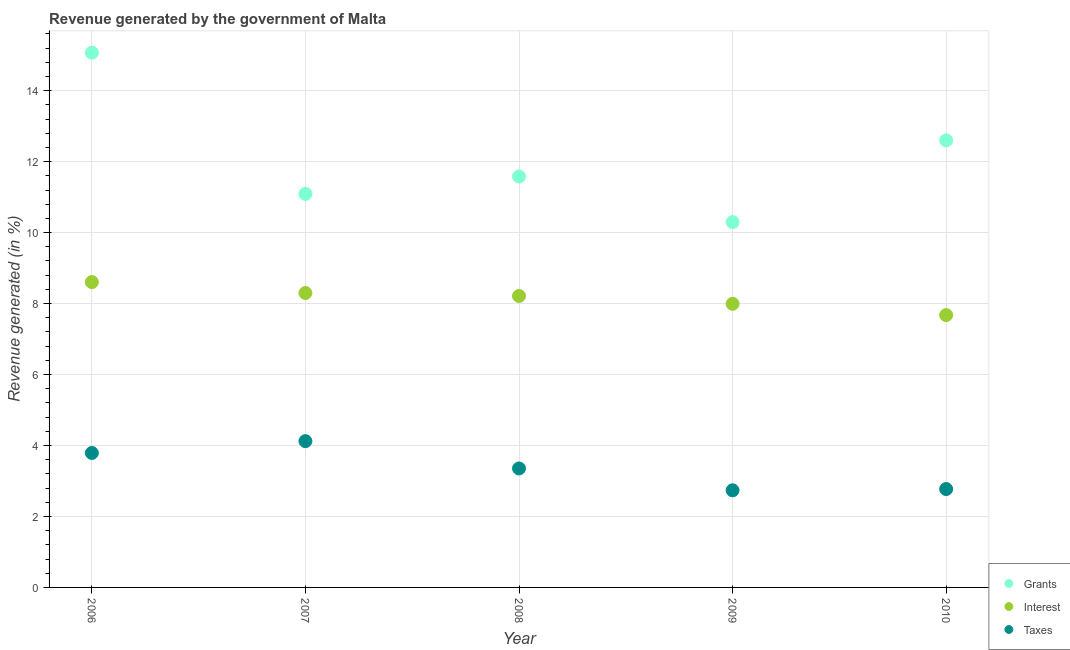How many different coloured dotlines are there?
Keep it short and to the point. 3. Is the number of dotlines equal to the number of legend labels?
Provide a succinct answer. Yes. What is the percentage of revenue generated by grants in 2010?
Give a very brief answer. 12.6. Across all years, what is the maximum percentage of revenue generated by taxes?
Give a very brief answer. 4.12. Across all years, what is the minimum percentage of revenue generated by interest?
Offer a terse response. 7.67. In which year was the percentage of revenue generated by taxes maximum?
Provide a succinct answer. 2007. In which year was the percentage of revenue generated by taxes minimum?
Provide a short and direct response. 2009. What is the total percentage of revenue generated by taxes in the graph?
Ensure brevity in your answer.  16.77. What is the difference between the percentage of revenue generated by interest in 2007 and that in 2009?
Provide a short and direct response. 0.3. What is the difference between the percentage of revenue generated by taxes in 2006 and the percentage of revenue generated by interest in 2009?
Give a very brief answer. -4.2. What is the average percentage of revenue generated by interest per year?
Your response must be concise. 8.16. In the year 2006, what is the difference between the percentage of revenue generated by grants and percentage of revenue generated by interest?
Your response must be concise. 6.46. What is the ratio of the percentage of revenue generated by taxes in 2006 to that in 2007?
Give a very brief answer. 0.92. Is the percentage of revenue generated by taxes in 2006 less than that in 2008?
Your response must be concise. No. Is the difference between the percentage of revenue generated by grants in 2006 and 2008 greater than the difference between the percentage of revenue generated by taxes in 2006 and 2008?
Give a very brief answer. Yes. What is the difference between the highest and the second highest percentage of revenue generated by taxes?
Keep it short and to the point. 0.33. What is the difference between the highest and the lowest percentage of revenue generated by taxes?
Offer a very short reply. 1.38. In how many years, is the percentage of revenue generated by grants greater than the average percentage of revenue generated by grants taken over all years?
Your response must be concise. 2. What is the difference between two consecutive major ticks on the Y-axis?
Keep it short and to the point. 2. Does the graph contain any zero values?
Ensure brevity in your answer.  No. How many legend labels are there?
Offer a terse response. 3. How are the legend labels stacked?
Your response must be concise. Vertical. What is the title of the graph?
Offer a terse response. Revenue generated by the government of Malta. What is the label or title of the X-axis?
Give a very brief answer. Year. What is the label or title of the Y-axis?
Provide a succinct answer. Revenue generated (in %). What is the Revenue generated (in %) in Grants in 2006?
Provide a short and direct response. 15.07. What is the Revenue generated (in %) in Interest in 2006?
Your answer should be compact. 8.6. What is the Revenue generated (in %) of Taxes in 2006?
Give a very brief answer. 3.79. What is the Revenue generated (in %) in Grants in 2007?
Offer a very short reply. 11.09. What is the Revenue generated (in %) in Interest in 2007?
Your response must be concise. 8.3. What is the Revenue generated (in %) of Taxes in 2007?
Your response must be concise. 4.12. What is the Revenue generated (in %) of Grants in 2008?
Offer a very short reply. 11.58. What is the Revenue generated (in %) in Interest in 2008?
Your answer should be very brief. 8.21. What is the Revenue generated (in %) in Taxes in 2008?
Ensure brevity in your answer.  3.35. What is the Revenue generated (in %) of Grants in 2009?
Keep it short and to the point. 10.3. What is the Revenue generated (in %) in Interest in 2009?
Your response must be concise. 7.99. What is the Revenue generated (in %) in Taxes in 2009?
Your response must be concise. 2.74. What is the Revenue generated (in %) of Grants in 2010?
Your answer should be compact. 12.6. What is the Revenue generated (in %) in Interest in 2010?
Ensure brevity in your answer.  7.67. What is the Revenue generated (in %) in Taxes in 2010?
Offer a terse response. 2.77. Across all years, what is the maximum Revenue generated (in %) of Grants?
Offer a very short reply. 15.07. Across all years, what is the maximum Revenue generated (in %) of Interest?
Ensure brevity in your answer.  8.6. Across all years, what is the maximum Revenue generated (in %) in Taxes?
Your answer should be very brief. 4.12. Across all years, what is the minimum Revenue generated (in %) in Grants?
Make the answer very short. 10.3. Across all years, what is the minimum Revenue generated (in %) of Interest?
Offer a terse response. 7.67. Across all years, what is the minimum Revenue generated (in %) in Taxes?
Make the answer very short. 2.74. What is the total Revenue generated (in %) in Grants in the graph?
Offer a very short reply. 60.63. What is the total Revenue generated (in %) in Interest in the graph?
Your answer should be very brief. 40.78. What is the total Revenue generated (in %) of Taxes in the graph?
Give a very brief answer. 16.77. What is the difference between the Revenue generated (in %) of Grants in 2006 and that in 2007?
Give a very brief answer. 3.98. What is the difference between the Revenue generated (in %) in Interest in 2006 and that in 2007?
Make the answer very short. 0.31. What is the difference between the Revenue generated (in %) of Taxes in 2006 and that in 2007?
Ensure brevity in your answer.  -0.33. What is the difference between the Revenue generated (in %) of Grants in 2006 and that in 2008?
Make the answer very short. 3.49. What is the difference between the Revenue generated (in %) in Interest in 2006 and that in 2008?
Give a very brief answer. 0.39. What is the difference between the Revenue generated (in %) in Taxes in 2006 and that in 2008?
Provide a succinct answer. 0.44. What is the difference between the Revenue generated (in %) in Grants in 2006 and that in 2009?
Your response must be concise. 4.77. What is the difference between the Revenue generated (in %) of Interest in 2006 and that in 2009?
Your answer should be very brief. 0.61. What is the difference between the Revenue generated (in %) of Taxes in 2006 and that in 2009?
Make the answer very short. 1.05. What is the difference between the Revenue generated (in %) in Grants in 2006 and that in 2010?
Your answer should be compact. 2.47. What is the difference between the Revenue generated (in %) of Interest in 2006 and that in 2010?
Offer a terse response. 0.93. What is the difference between the Revenue generated (in %) of Grants in 2007 and that in 2008?
Provide a short and direct response. -0.49. What is the difference between the Revenue generated (in %) of Interest in 2007 and that in 2008?
Provide a succinct answer. 0.08. What is the difference between the Revenue generated (in %) of Taxes in 2007 and that in 2008?
Provide a short and direct response. 0.77. What is the difference between the Revenue generated (in %) in Grants in 2007 and that in 2009?
Give a very brief answer. 0.79. What is the difference between the Revenue generated (in %) in Interest in 2007 and that in 2009?
Provide a short and direct response. 0.3. What is the difference between the Revenue generated (in %) in Taxes in 2007 and that in 2009?
Make the answer very short. 1.38. What is the difference between the Revenue generated (in %) of Grants in 2007 and that in 2010?
Provide a succinct answer. -1.51. What is the difference between the Revenue generated (in %) in Interest in 2007 and that in 2010?
Give a very brief answer. 0.62. What is the difference between the Revenue generated (in %) of Taxes in 2007 and that in 2010?
Your answer should be compact. 1.35. What is the difference between the Revenue generated (in %) in Grants in 2008 and that in 2009?
Your answer should be compact. 1.28. What is the difference between the Revenue generated (in %) of Interest in 2008 and that in 2009?
Offer a terse response. 0.22. What is the difference between the Revenue generated (in %) of Taxes in 2008 and that in 2009?
Ensure brevity in your answer.  0.62. What is the difference between the Revenue generated (in %) in Grants in 2008 and that in 2010?
Provide a succinct answer. -1.02. What is the difference between the Revenue generated (in %) in Interest in 2008 and that in 2010?
Provide a succinct answer. 0.54. What is the difference between the Revenue generated (in %) in Taxes in 2008 and that in 2010?
Ensure brevity in your answer.  0.58. What is the difference between the Revenue generated (in %) of Grants in 2009 and that in 2010?
Your response must be concise. -2.3. What is the difference between the Revenue generated (in %) of Interest in 2009 and that in 2010?
Keep it short and to the point. 0.32. What is the difference between the Revenue generated (in %) in Taxes in 2009 and that in 2010?
Make the answer very short. -0.03. What is the difference between the Revenue generated (in %) in Grants in 2006 and the Revenue generated (in %) in Interest in 2007?
Provide a short and direct response. 6.77. What is the difference between the Revenue generated (in %) of Grants in 2006 and the Revenue generated (in %) of Taxes in 2007?
Make the answer very short. 10.95. What is the difference between the Revenue generated (in %) in Interest in 2006 and the Revenue generated (in %) in Taxes in 2007?
Your response must be concise. 4.48. What is the difference between the Revenue generated (in %) of Grants in 2006 and the Revenue generated (in %) of Interest in 2008?
Make the answer very short. 6.86. What is the difference between the Revenue generated (in %) in Grants in 2006 and the Revenue generated (in %) in Taxes in 2008?
Your answer should be very brief. 11.72. What is the difference between the Revenue generated (in %) in Interest in 2006 and the Revenue generated (in %) in Taxes in 2008?
Your answer should be compact. 5.25. What is the difference between the Revenue generated (in %) in Grants in 2006 and the Revenue generated (in %) in Interest in 2009?
Keep it short and to the point. 7.08. What is the difference between the Revenue generated (in %) of Grants in 2006 and the Revenue generated (in %) of Taxes in 2009?
Provide a short and direct response. 12.33. What is the difference between the Revenue generated (in %) of Interest in 2006 and the Revenue generated (in %) of Taxes in 2009?
Make the answer very short. 5.87. What is the difference between the Revenue generated (in %) of Grants in 2006 and the Revenue generated (in %) of Interest in 2010?
Your response must be concise. 7.39. What is the difference between the Revenue generated (in %) in Grants in 2006 and the Revenue generated (in %) in Taxes in 2010?
Keep it short and to the point. 12.3. What is the difference between the Revenue generated (in %) of Interest in 2006 and the Revenue generated (in %) of Taxes in 2010?
Your answer should be compact. 5.83. What is the difference between the Revenue generated (in %) of Grants in 2007 and the Revenue generated (in %) of Interest in 2008?
Offer a very short reply. 2.88. What is the difference between the Revenue generated (in %) of Grants in 2007 and the Revenue generated (in %) of Taxes in 2008?
Your answer should be compact. 7.74. What is the difference between the Revenue generated (in %) of Interest in 2007 and the Revenue generated (in %) of Taxes in 2008?
Offer a very short reply. 4.94. What is the difference between the Revenue generated (in %) in Grants in 2007 and the Revenue generated (in %) in Interest in 2009?
Offer a terse response. 3.1. What is the difference between the Revenue generated (in %) of Grants in 2007 and the Revenue generated (in %) of Taxes in 2009?
Provide a short and direct response. 8.35. What is the difference between the Revenue generated (in %) of Interest in 2007 and the Revenue generated (in %) of Taxes in 2009?
Offer a very short reply. 5.56. What is the difference between the Revenue generated (in %) of Grants in 2007 and the Revenue generated (in %) of Interest in 2010?
Make the answer very short. 3.42. What is the difference between the Revenue generated (in %) of Grants in 2007 and the Revenue generated (in %) of Taxes in 2010?
Your answer should be very brief. 8.32. What is the difference between the Revenue generated (in %) in Interest in 2007 and the Revenue generated (in %) in Taxes in 2010?
Keep it short and to the point. 5.53. What is the difference between the Revenue generated (in %) in Grants in 2008 and the Revenue generated (in %) in Interest in 2009?
Keep it short and to the point. 3.59. What is the difference between the Revenue generated (in %) of Grants in 2008 and the Revenue generated (in %) of Taxes in 2009?
Provide a succinct answer. 8.84. What is the difference between the Revenue generated (in %) of Interest in 2008 and the Revenue generated (in %) of Taxes in 2009?
Offer a terse response. 5.48. What is the difference between the Revenue generated (in %) in Grants in 2008 and the Revenue generated (in %) in Interest in 2010?
Give a very brief answer. 3.91. What is the difference between the Revenue generated (in %) of Grants in 2008 and the Revenue generated (in %) of Taxes in 2010?
Your answer should be very brief. 8.81. What is the difference between the Revenue generated (in %) in Interest in 2008 and the Revenue generated (in %) in Taxes in 2010?
Keep it short and to the point. 5.44. What is the difference between the Revenue generated (in %) of Grants in 2009 and the Revenue generated (in %) of Interest in 2010?
Keep it short and to the point. 2.62. What is the difference between the Revenue generated (in %) of Grants in 2009 and the Revenue generated (in %) of Taxes in 2010?
Your answer should be very brief. 7.52. What is the difference between the Revenue generated (in %) in Interest in 2009 and the Revenue generated (in %) in Taxes in 2010?
Ensure brevity in your answer.  5.22. What is the average Revenue generated (in %) of Grants per year?
Your answer should be compact. 12.13. What is the average Revenue generated (in %) in Interest per year?
Keep it short and to the point. 8.16. What is the average Revenue generated (in %) of Taxes per year?
Your response must be concise. 3.35. In the year 2006, what is the difference between the Revenue generated (in %) of Grants and Revenue generated (in %) of Interest?
Ensure brevity in your answer.  6.46. In the year 2006, what is the difference between the Revenue generated (in %) in Grants and Revenue generated (in %) in Taxes?
Your answer should be compact. 11.28. In the year 2006, what is the difference between the Revenue generated (in %) in Interest and Revenue generated (in %) in Taxes?
Provide a succinct answer. 4.82. In the year 2007, what is the difference between the Revenue generated (in %) in Grants and Revenue generated (in %) in Interest?
Provide a short and direct response. 2.79. In the year 2007, what is the difference between the Revenue generated (in %) of Grants and Revenue generated (in %) of Taxes?
Your response must be concise. 6.97. In the year 2007, what is the difference between the Revenue generated (in %) of Interest and Revenue generated (in %) of Taxes?
Provide a short and direct response. 4.17. In the year 2008, what is the difference between the Revenue generated (in %) of Grants and Revenue generated (in %) of Interest?
Your response must be concise. 3.37. In the year 2008, what is the difference between the Revenue generated (in %) of Grants and Revenue generated (in %) of Taxes?
Offer a terse response. 8.23. In the year 2008, what is the difference between the Revenue generated (in %) of Interest and Revenue generated (in %) of Taxes?
Make the answer very short. 4.86. In the year 2009, what is the difference between the Revenue generated (in %) of Grants and Revenue generated (in %) of Interest?
Keep it short and to the point. 2.3. In the year 2009, what is the difference between the Revenue generated (in %) in Grants and Revenue generated (in %) in Taxes?
Your answer should be compact. 7.56. In the year 2009, what is the difference between the Revenue generated (in %) in Interest and Revenue generated (in %) in Taxes?
Your answer should be compact. 5.25. In the year 2010, what is the difference between the Revenue generated (in %) in Grants and Revenue generated (in %) in Interest?
Offer a terse response. 4.92. In the year 2010, what is the difference between the Revenue generated (in %) of Grants and Revenue generated (in %) of Taxes?
Offer a terse response. 9.83. In the year 2010, what is the difference between the Revenue generated (in %) in Interest and Revenue generated (in %) in Taxes?
Give a very brief answer. 4.9. What is the ratio of the Revenue generated (in %) of Grants in 2006 to that in 2007?
Provide a succinct answer. 1.36. What is the ratio of the Revenue generated (in %) of Interest in 2006 to that in 2007?
Make the answer very short. 1.04. What is the ratio of the Revenue generated (in %) in Taxes in 2006 to that in 2007?
Ensure brevity in your answer.  0.92. What is the ratio of the Revenue generated (in %) in Grants in 2006 to that in 2008?
Keep it short and to the point. 1.3. What is the ratio of the Revenue generated (in %) in Interest in 2006 to that in 2008?
Keep it short and to the point. 1.05. What is the ratio of the Revenue generated (in %) in Taxes in 2006 to that in 2008?
Your answer should be compact. 1.13. What is the ratio of the Revenue generated (in %) of Grants in 2006 to that in 2009?
Your response must be concise. 1.46. What is the ratio of the Revenue generated (in %) of Interest in 2006 to that in 2009?
Your answer should be compact. 1.08. What is the ratio of the Revenue generated (in %) in Taxes in 2006 to that in 2009?
Make the answer very short. 1.38. What is the ratio of the Revenue generated (in %) in Grants in 2006 to that in 2010?
Make the answer very short. 1.2. What is the ratio of the Revenue generated (in %) of Interest in 2006 to that in 2010?
Offer a terse response. 1.12. What is the ratio of the Revenue generated (in %) in Taxes in 2006 to that in 2010?
Ensure brevity in your answer.  1.37. What is the ratio of the Revenue generated (in %) in Grants in 2007 to that in 2008?
Make the answer very short. 0.96. What is the ratio of the Revenue generated (in %) of Interest in 2007 to that in 2008?
Give a very brief answer. 1.01. What is the ratio of the Revenue generated (in %) of Taxes in 2007 to that in 2008?
Your answer should be very brief. 1.23. What is the ratio of the Revenue generated (in %) of Grants in 2007 to that in 2009?
Offer a very short reply. 1.08. What is the ratio of the Revenue generated (in %) in Interest in 2007 to that in 2009?
Keep it short and to the point. 1.04. What is the ratio of the Revenue generated (in %) of Taxes in 2007 to that in 2009?
Offer a terse response. 1.51. What is the ratio of the Revenue generated (in %) of Grants in 2007 to that in 2010?
Your response must be concise. 0.88. What is the ratio of the Revenue generated (in %) in Interest in 2007 to that in 2010?
Offer a terse response. 1.08. What is the ratio of the Revenue generated (in %) of Taxes in 2007 to that in 2010?
Ensure brevity in your answer.  1.49. What is the ratio of the Revenue generated (in %) of Grants in 2008 to that in 2009?
Your response must be concise. 1.12. What is the ratio of the Revenue generated (in %) in Interest in 2008 to that in 2009?
Your answer should be very brief. 1.03. What is the ratio of the Revenue generated (in %) in Taxes in 2008 to that in 2009?
Your response must be concise. 1.22. What is the ratio of the Revenue generated (in %) in Grants in 2008 to that in 2010?
Offer a very short reply. 0.92. What is the ratio of the Revenue generated (in %) of Interest in 2008 to that in 2010?
Give a very brief answer. 1.07. What is the ratio of the Revenue generated (in %) of Taxes in 2008 to that in 2010?
Offer a very short reply. 1.21. What is the ratio of the Revenue generated (in %) in Grants in 2009 to that in 2010?
Make the answer very short. 0.82. What is the ratio of the Revenue generated (in %) of Interest in 2009 to that in 2010?
Your answer should be very brief. 1.04. What is the ratio of the Revenue generated (in %) of Taxes in 2009 to that in 2010?
Give a very brief answer. 0.99. What is the difference between the highest and the second highest Revenue generated (in %) in Grants?
Your answer should be very brief. 2.47. What is the difference between the highest and the second highest Revenue generated (in %) in Interest?
Your answer should be very brief. 0.31. What is the difference between the highest and the second highest Revenue generated (in %) in Taxes?
Your answer should be very brief. 0.33. What is the difference between the highest and the lowest Revenue generated (in %) of Grants?
Offer a very short reply. 4.77. What is the difference between the highest and the lowest Revenue generated (in %) in Interest?
Offer a terse response. 0.93. What is the difference between the highest and the lowest Revenue generated (in %) of Taxes?
Make the answer very short. 1.38. 